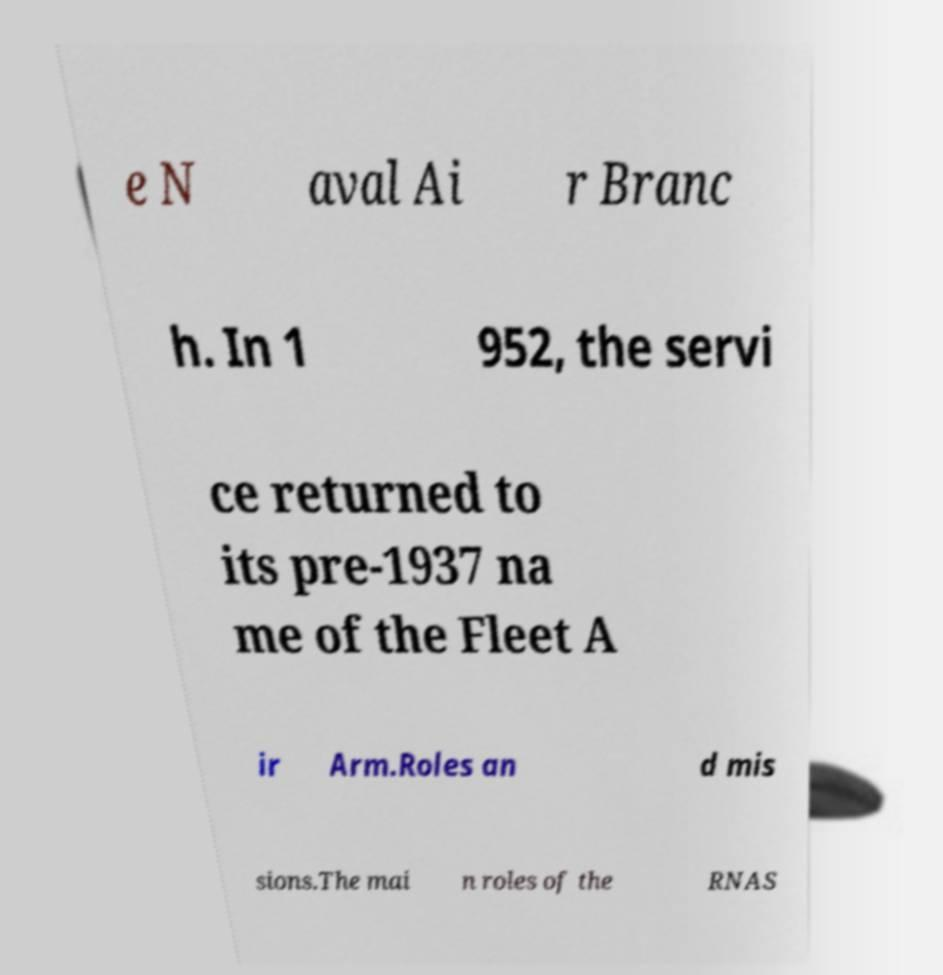Can you read and provide the text displayed in the image?This photo seems to have some interesting text. Can you extract and type it out for me? e N aval Ai r Branc h. In 1 952, the servi ce returned to its pre-1937 na me of the Fleet A ir Arm.Roles an d mis sions.The mai n roles of the RNAS 